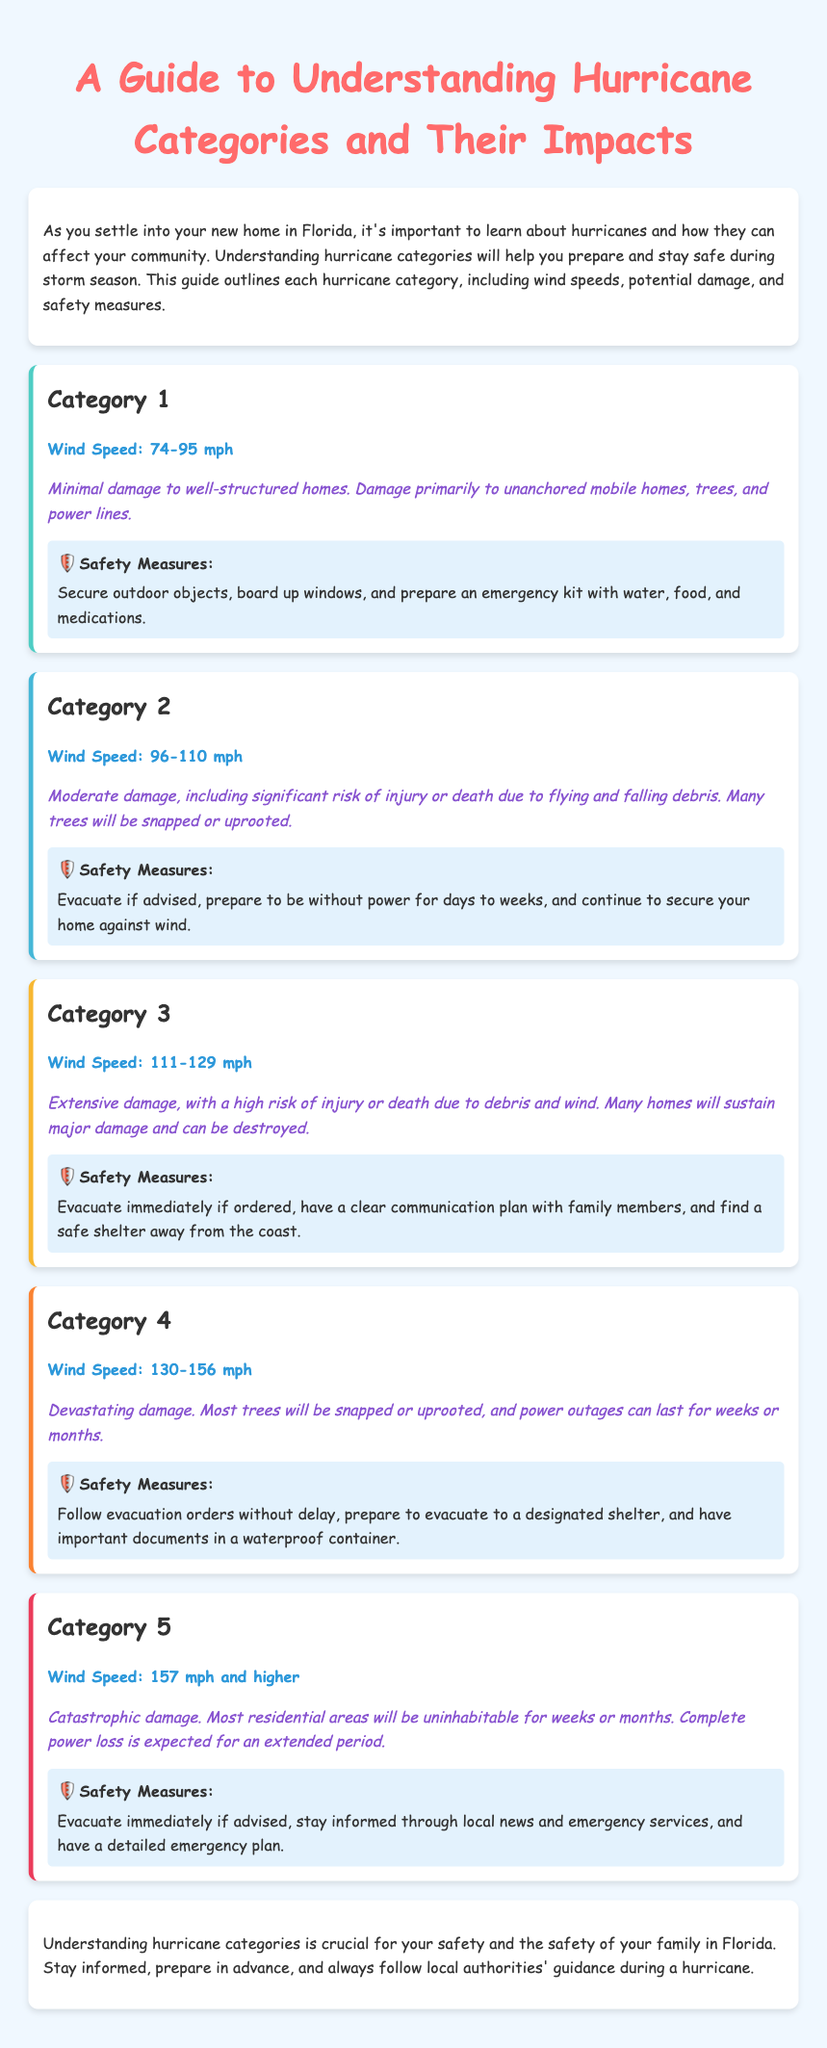What is the wind speed range for Category 1? The wind speed range for Category 1 is specified in the document as 74-95 mph.
Answer: 74-95 mph What potential damage can a Category 4 hurricane cause? The document states that a Category 4 hurricane can cause devastating damage including snapped or uprooted trees and extended power outages.
Answer: Devastating damage What safety measures are recommended for a Category 5 hurricane? The document advises to evacuate immediately if advised, stay informed, and have a detailed emergency plan for Category 5 hurricanes.
Answer: Evacuate immediately if advised How many hurricane categories are discussed in the guide? The guide discusses a total of 5 hurricane categories, as outlined at the beginning.
Answer: 5 What is the wind speed for Category 3? The document specifies that the wind speed for Category 3 hurricanes is between 111-129 mph.
Answer: 111-129 mph What should you prepare for if a Category 2 hurricane approaches? The document mentions preparing to be without power for days to weeks as a key measure for Category 2 hurricanes.
Answer: Prepare to be without power for days to weeks What is the minimum wind speed for a hurricane to be classified as Category 1? The document sets the minimum wind speed for Category 1 hurricanes at 74 mph.
Answer: 74 mph 